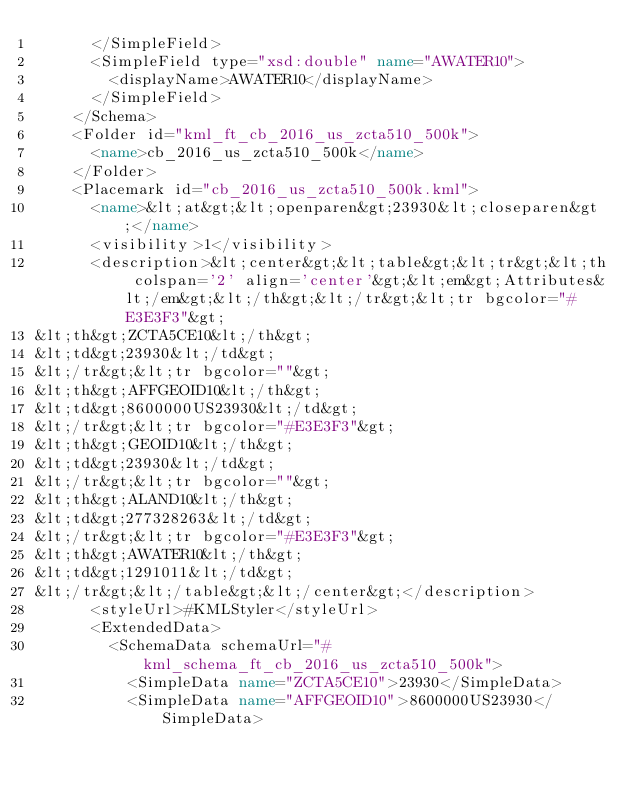<code> <loc_0><loc_0><loc_500><loc_500><_XML_>      </SimpleField>
      <SimpleField type="xsd:double" name="AWATER10">
        <displayName>AWATER10</displayName>
      </SimpleField>
    </Schema>
    <Folder id="kml_ft_cb_2016_us_zcta510_500k">
      <name>cb_2016_us_zcta510_500k</name>
    </Folder>
    <Placemark id="cb_2016_us_zcta510_500k.kml">
      <name>&lt;at&gt;&lt;openparen&gt;23930&lt;closeparen&gt;</name>
      <visibility>1</visibility>
      <description>&lt;center&gt;&lt;table&gt;&lt;tr&gt;&lt;th colspan='2' align='center'&gt;&lt;em&gt;Attributes&lt;/em&gt;&lt;/th&gt;&lt;/tr&gt;&lt;tr bgcolor="#E3E3F3"&gt;
&lt;th&gt;ZCTA5CE10&lt;/th&gt;
&lt;td&gt;23930&lt;/td&gt;
&lt;/tr&gt;&lt;tr bgcolor=""&gt;
&lt;th&gt;AFFGEOID10&lt;/th&gt;
&lt;td&gt;8600000US23930&lt;/td&gt;
&lt;/tr&gt;&lt;tr bgcolor="#E3E3F3"&gt;
&lt;th&gt;GEOID10&lt;/th&gt;
&lt;td&gt;23930&lt;/td&gt;
&lt;/tr&gt;&lt;tr bgcolor=""&gt;
&lt;th&gt;ALAND10&lt;/th&gt;
&lt;td&gt;277328263&lt;/td&gt;
&lt;/tr&gt;&lt;tr bgcolor="#E3E3F3"&gt;
&lt;th&gt;AWATER10&lt;/th&gt;
&lt;td&gt;1291011&lt;/td&gt;
&lt;/tr&gt;&lt;/table&gt;&lt;/center&gt;</description>
      <styleUrl>#KMLStyler</styleUrl>
      <ExtendedData>
        <SchemaData schemaUrl="#kml_schema_ft_cb_2016_us_zcta510_500k">
          <SimpleData name="ZCTA5CE10">23930</SimpleData>
          <SimpleData name="AFFGEOID10">8600000US23930</SimpleData></code> 